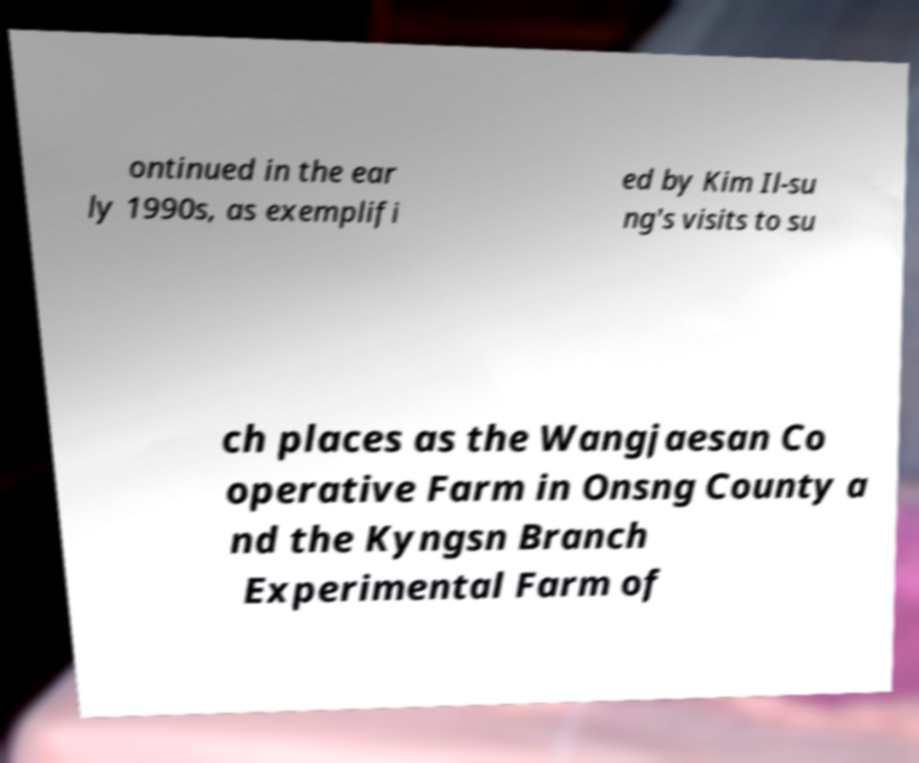Could you extract and type out the text from this image? ontinued in the ear ly 1990s, as exemplifi ed by Kim Il-su ng's visits to su ch places as the Wangjaesan Co operative Farm in Onsng County a nd the Kyngsn Branch Experimental Farm of 